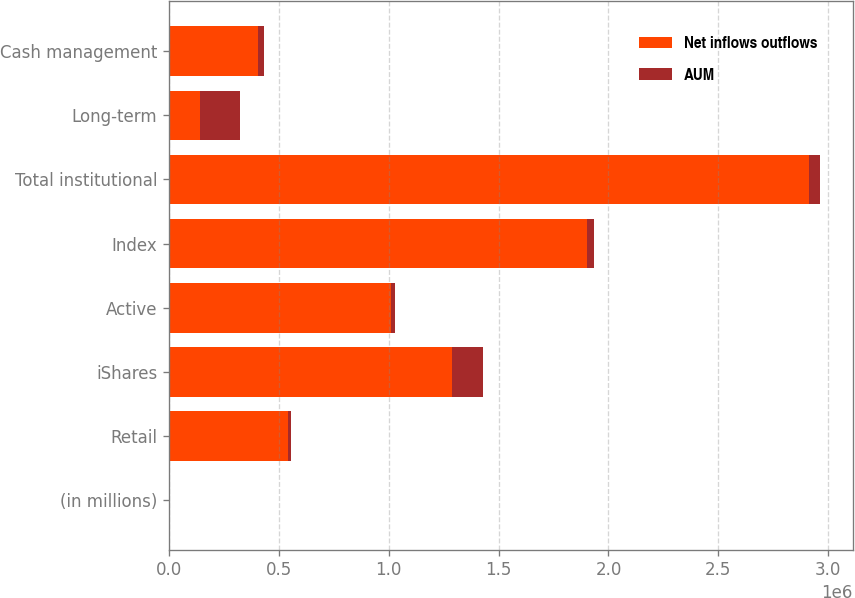<chart> <loc_0><loc_0><loc_500><loc_500><stacked_bar_chart><ecel><fcel>(in millions)<fcel>Retail<fcel>iShares<fcel>Active<fcel>Index<fcel>Total institutional<fcel>Long-term<fcel>Cash management<nl><fcel>Net inflows outflows<fcel>2016<fcel>541952<fcel>1.28788e+06<fcel>1.00997e+06<fcel>1.90168e+06<fcel>2.91166e+06<fcel>140479<fcel>403584<nl><fcel>AUM<fcel>2016<fcel>11324<fcel>140479<fcel>17918<fcel>33491<fcel>51409<fcel>180564<fcel>29228<nl></chart> 